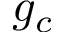Convert formula to latex. <formula><loc_0><loc_0><loc_500><loc_500>g _ { c }</formula> 